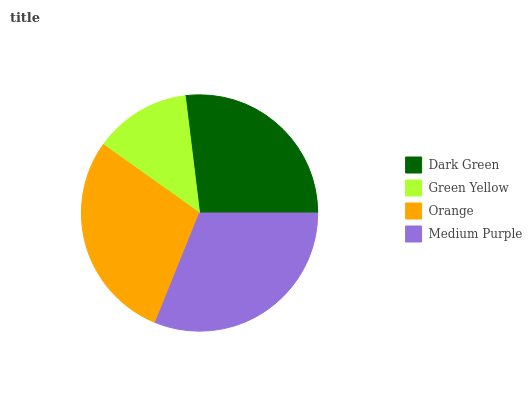Is Green Yellow the minimum?
Answer yes or no. Yes. Is Medium Purple the maximum?
Answer yes or no. Yes. Is Orange the minimum?
Answer yes or no. No. Is Orange the maximum?
Answer yes or no. No. Is Orange greater than Green Yellow?
Answer yes or no. Yes. Is Green Yellow less than Orange?
Answer yes or no. Yes. Is Green Yellow greater than Orange?
Answer yes or no. No. Is Orange less than Green Yellow?
Answer yes or no. No. Is Orange the high median?
Answer yes or no. Yes. Is Dark Green the low median?
Answer yes or no. Yes. Is Green Yellow the high median?
Answer yes or no. No. Is Orange the low median?
Answer yes or no. No. 